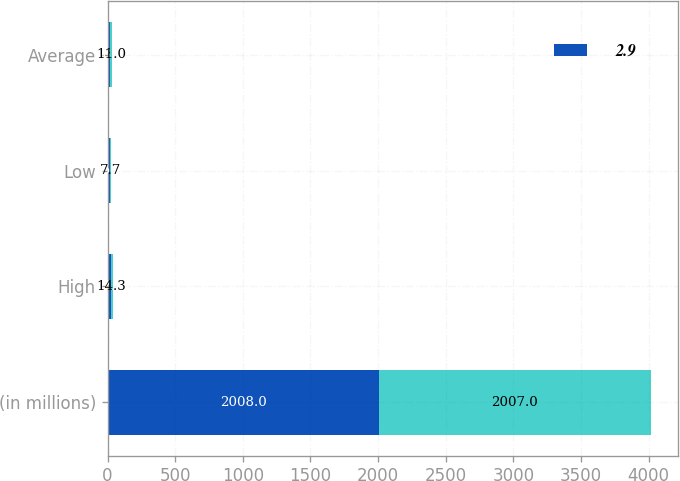Convert chart to OTSL. <chart><loc_0><loc_0><loc_500><loc_500><stacked_bar_chart><ecel><fcel>(in millions)<fcel>High<fcel>Low<fcel>Average<nl><fcel>2.9<fcel>2008<fcel>22.2<fcel>15<fcel>18.5<nl><fcel>nan<fcel>2007<fcel>14.3<fcel>7.7<fcel>11<nl></chart> 